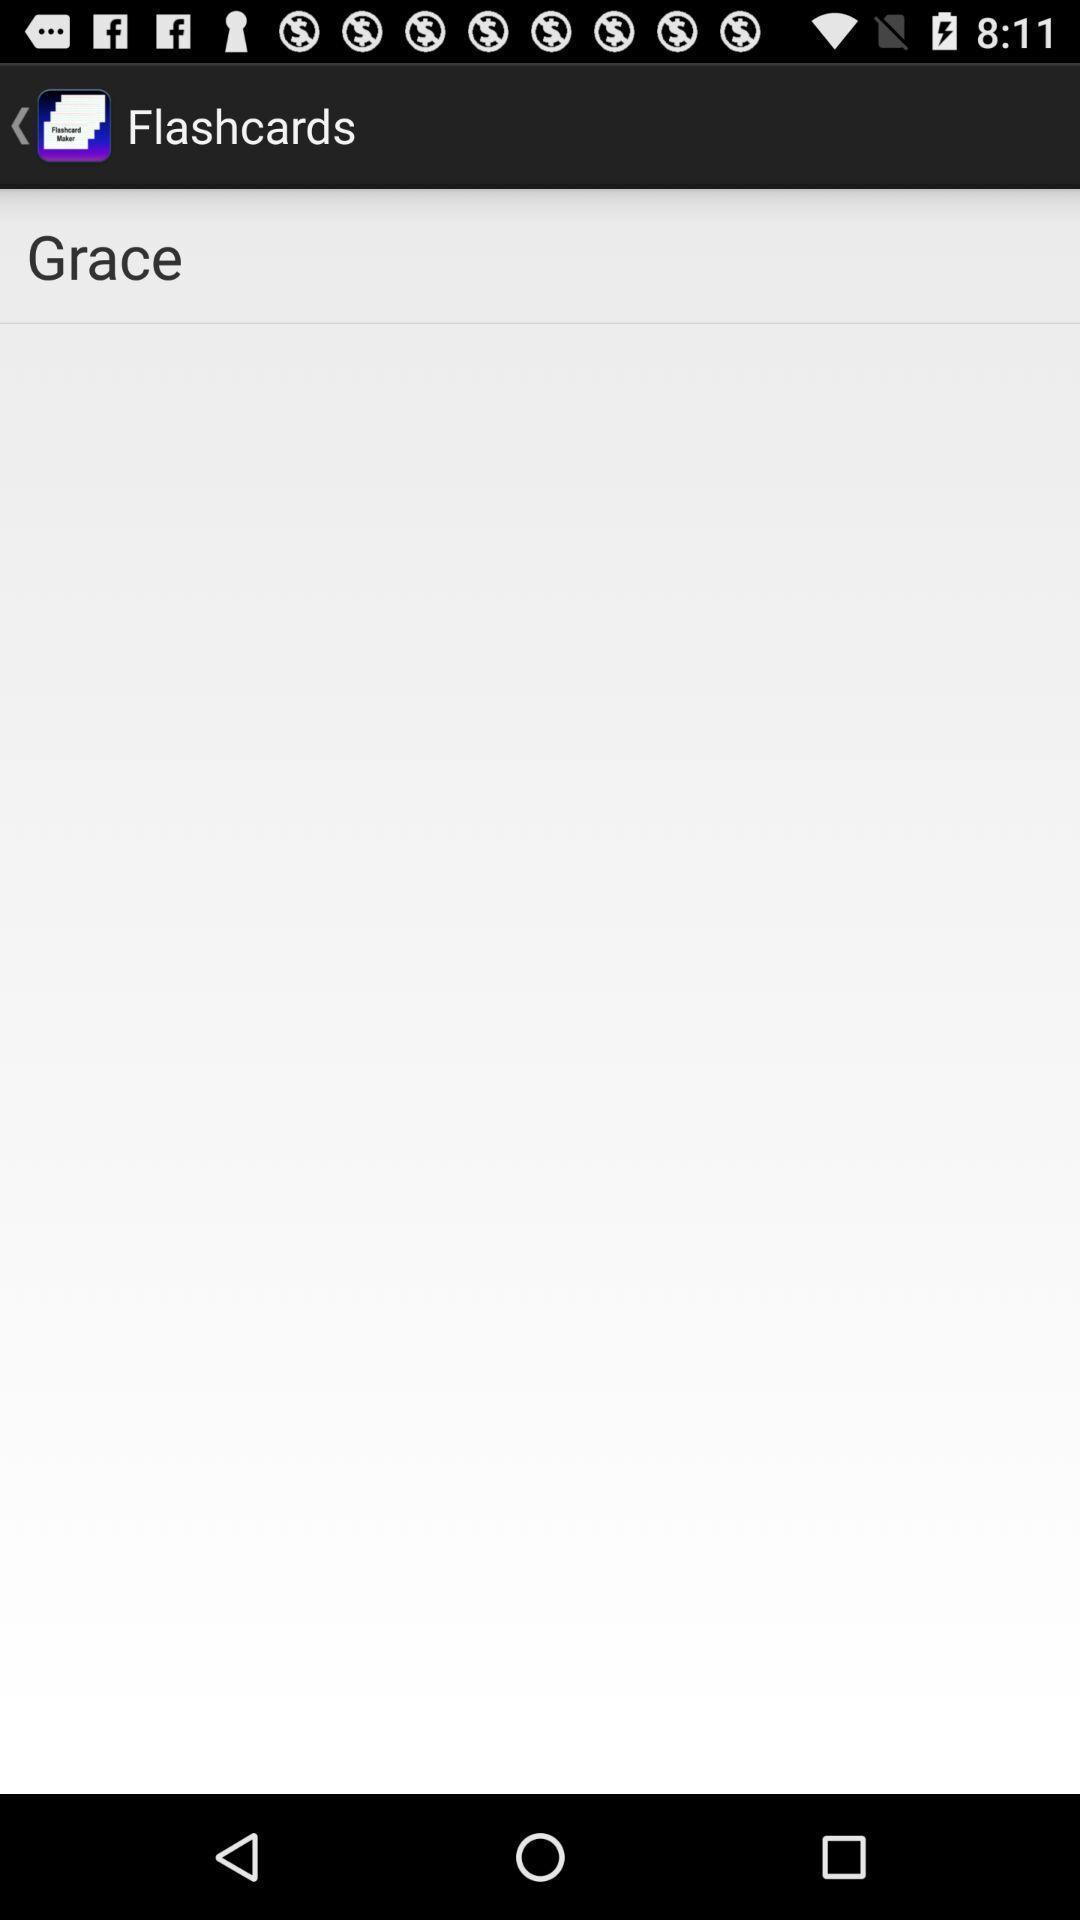Describe this image in words. Screen page. 